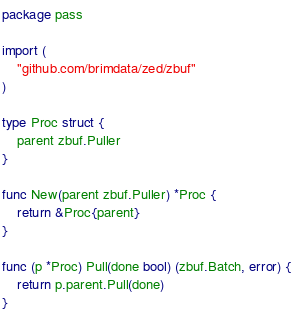<code> <loc_0><loc_0><loc_500><loc_500><_Go_>package pass

import (
	"github.com/brimdata/zed/zbuf"
)

type Proc struct {
	parent zbuf.Puller
}

func New(parent zbuf.Puller) *Proc {
	return &Proc{parent}
}

func (p *Proc) Pull(done bool) (zbuf.Batch, error) {
	return p.parent.Pull(done)
}
</code> 